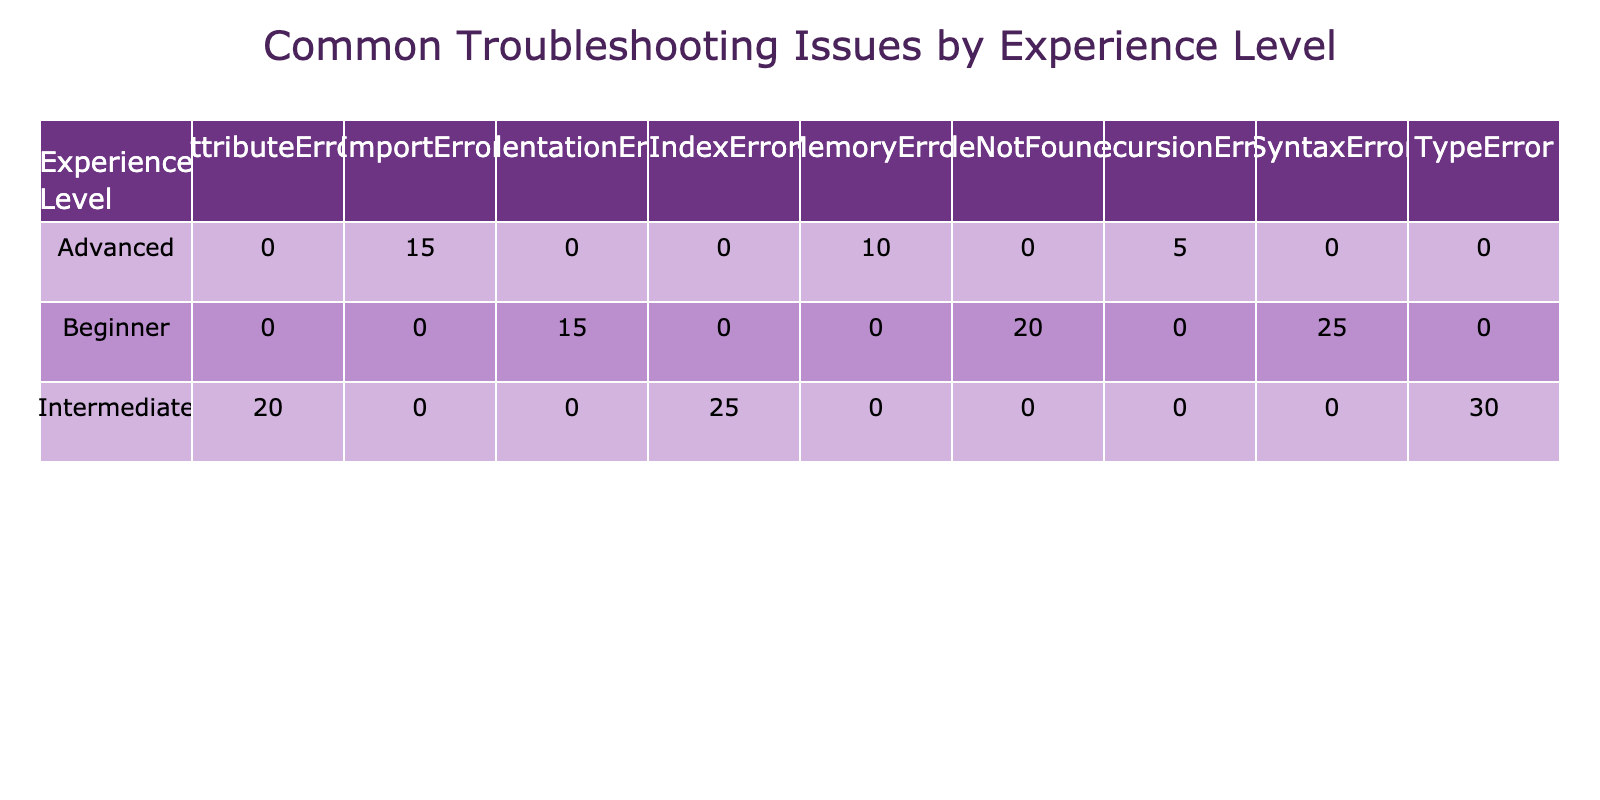What is the frequency of SyntaxError for Beginners? The table shows the frequency of various troubleshooting issues faced by users at different experience levels. For Beginners, the specific troubleshooting issue of SyntaxError is listed with a frequency of 25.
Answer: 25 Which troubleshooting issue has the highest frequency among Intermediate users? Looking at the Intermediate users in the table, we can see three troubleshooting issues listed: TypeError (30), IndexError (25), and AttributeError (20). The highest frequency is for TypeError with 30.
Answer: 30 Is it true that Advanced users face more MemoryError than RecursionError? For Advanced users, the frequencies for MemoryError and RecursionError are 10 and 5 respectively. Since 10 (MemoryError) is greater than 5 (RecursionError), the statement is true.
Answer: Yes What is the total frequency of troubleshooting issues for Beginners? By summing the frequencies for the troubleshooting issues specific to Beginners, we have (25 + 15 + 20) = 60. Thus, the total frequency for Beginners is 60.
Answer: 60 How many different troubleshooting issues do Intermediate users face? The table displays three troubleshooting issues for Intermediate users: TypeError, IndexError, and AttributeError, indicating that Intermediate users face a total of 3 different issues.
Answer: 3 What is the difference in frequency between the most common issue for Beginners and the most common issue for Advanced users? By examining the table, the most common issue for Beginners is SyntaxError with a frequency of 25, and for Advanced users, the most common issue is ImportError with a frequency of 15. The difference calculated is (25 - 15) = 10.
Answer: 10 What is the average frequency of troubleshooting issues across all experience levels? To find the average frequency, first sum the frequencies: (25 + 15 + 20 + 30 + 25 + 20 + 10 + 15 + 5) = 175. Then, count the number of experience level categories: 3 (Beginner) + 3 (Intermediate) + 3 (Advanced) = 9 issues. Finally, calculate the average: 175 / 9 ≈ 19.44.
Answer: 19.44 